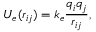Convert formula to latex. <formula><loc_0><loc_0><loc_500><loc_500>U _ { e } ( r _ { i j } ) = k _ { e } \frac { q _ { i } q _ { j } } { r _ { i j } } ,</formula> 